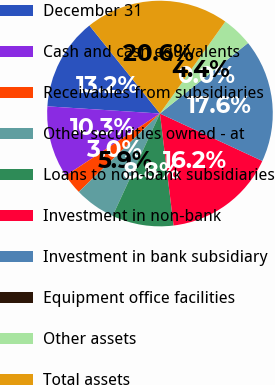<chart> <loc_0><loc_0><loc_500><loc_500><pie_chart><fcel>December 31<fcel>Cash and cash equivalents<fcel>Receivables from subsidiaries<fcel>Other securities owned - at<fcel>Loans to non-bank subsidiaries<fcel>Investment in non-bank<fcel>Investment in bank subsidiary<fcel>Equipment office facilities<fcel>Other assets<fcel>Total assets<nl><fcel>13.23%<fcel>10.29%<fcel>2.95%<fcel>5.88%<fcel>8.82%<fcel>16.17%<fcel>17.64%<fcel>0.01%<fcel>4.42%<fcel>20.58%<nl></chart> 